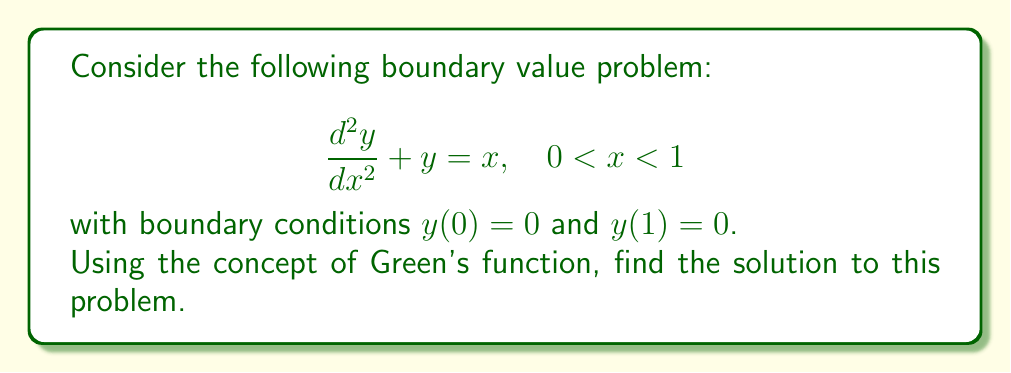Provide a solution to this math problem. Let's solve this step-by-step:

1) First, we need to find the Green's function for this problem. The homogeneous equation is:
   
   $$\frac{d^2y}{dx^2} + y = 0$$

2) The general solution to this equation is:
   
   $$y = A \cos(x) + B \sin(x)$$

3) The Green's function $G(x,s)$ must satisfy:
   
   $$\frac{\partial^2 G}{\partial x^2} + G = \delta(x-s)$$
   
   where $\delta$ is the Dirac delta function.

4) We can write $G(x,s)$ as:

   $$G(x,s) = \begin{cases} 
   A_1 \cos(x) + B_1 \sin(x), & 0 \leq x < s \\
   A_2 \cos(x) + B_2 \sin(x), & s < x \leq 1
   \end{cases}$$

5) We need to satisfy these conditions:
   - $G(0,s) = G(1,s) = 0$ (boundary conditions)
   - $G(s^-,s) = G(s^+,s)$ (continuity)
   - $\frac{\partial G}{\partial x}(s^+,s) - \frac{\partial G}{\partial x}(s^-,s) = 1$ (jump condition)

6) Applying these conditions, we get:

   $$G(x,s) = \begin{cases}
   \frac{\sin(s)\sin(1-x)}{\sin(1)}, & 0 \leq x < s \\
   \frac{\sin(x)\sin(1-s)}{\sin(1)}, & s < x \leq 1
   \end{cases}$$

7) Now, we can write the solution as:

   $$y(x) = \int_0^1 G(x,s)f(s)ds$$

   where $f(s) = s$ in our case.

8) Substituting and integrating:

   $$y(x) = \int_0^x \frac{\sin(s)\sin(1-x)}{\sin(1)}s ds + \int_x^1 \frac{\sin(x)\sin(1-s)}{\sin(1)}s ds$$

9) After integration and simplification, we get:

   $$y(x) = x - \sin(x)$$

This function satisfies the differential equation and the boundary conditions.
Answer: $y(x) = x - \sin(x)$ 